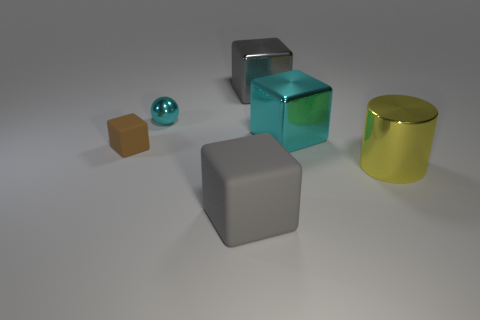What is the material of the large thing that is the same color as the metal sphere?
Keep it short and to the point. Metal. What is the material of the cyan block that is the same size as the shiny cylinder?
Give a very brief answer. Metal. There is a shiny sphere to the left of the large yellow object; how big is it?
Your answer should be very brief. Small. What is the material of the cylinder?
Provide a short and direct response. Metal. How many things are either things that are right of the brown cube or cyan metal things that are behind the cyan block?
Give a very brief answer. 5. What number of other things are the same color as the big shiny cylinder?
Ensure brevity in your answer.  0. There is a large gray shiny thing; is it the same shape as the big shiny thing in front of the big cyan thing?
Offer a terse response. No. Is the number of tiny matte cubes on the right side of the tiny brown matte cube less than the number of cyan metal cubes that are in front of the small cyan metallic object?
Your answer should be very brief. Yes. What is the material of the other gray thing that is the same shape as the gray matte thing?
Keep it short and to the point. Metal. Are there any other things that have the same material as the cyan ball?
Offer a very short reply. Yes. 